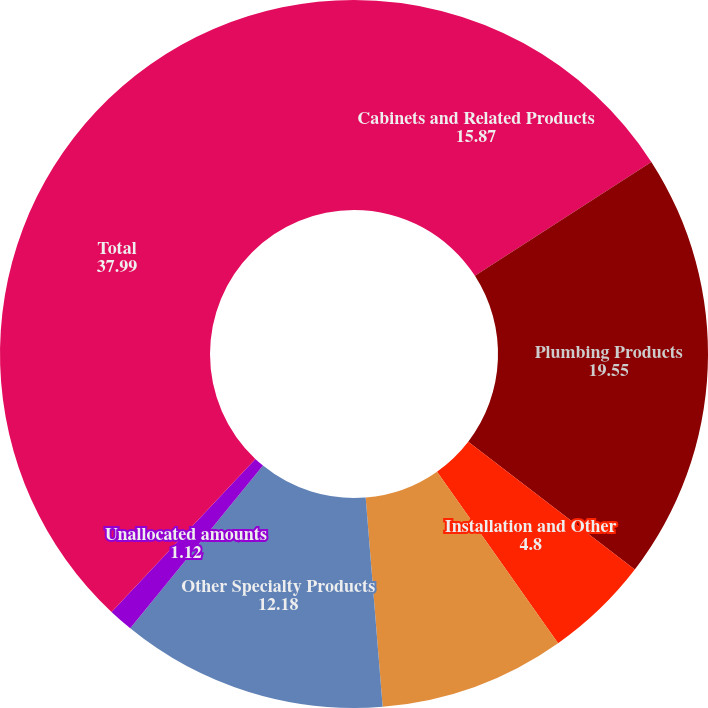Convert chart. <chart><loc_0><loc_0><loc_500><loc_500><pie_chart><fcel>Cabinets and Related Products<fcel>Plumbing Products<fcel>Installation and Other<fcel>Decorative Architectural<fcel>Other Specialty Products<fcel>Unallocated amounts<fcel>Total<nl><fcel>15.87%<fcel>19.55%<fcel>4.8%<fcel>8.49%<fcel>12.18%<fcel>1.12%<fcel>37.99%<nl></chart> 